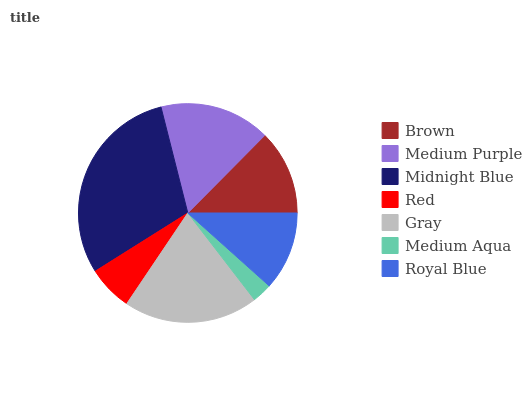Is Medium Aqua the minimum?
Answer yes or no. Yes. Is Midnight Blue the maximum?
Answer yes or no. Yes. Is Medium Purple the minimum?
Answer yes or no. No. Is Medium Purple the maximum?
Answer yes or no. No. Is Medium Purple greater than Brown?
Answer yes or no. Yes. Is Brown less than Medium Purple?
Answer yes or no. Yes. Is Brown greater than Medium Purple?
Answer yes or no. No. Is Medium Purple less than Brown?
Answer yes or no. No. Is Brown the high median?
Answer yes or no. Yes. Is Brown the low median?
Answer yes or no. Yes. Is Red the high median?
Answer yes or no. No. Is Royal Blue the low median?
Answer yes or no. No. 